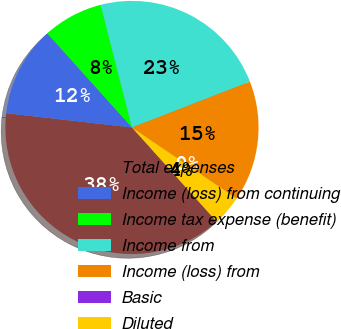<chart> <loc_0><loc_0><loc_500><loc_500><pie_chart><fcel>Total expenses<fcel>Income (loss) from continuing<fcel>Income tax expense (benefit)<fcel>Income from<fcel>Income (loss) from<fcel>Basic<fcel>Diluted<nl><fcel>38.46%<fcel>11.54%<fcel>7.69%<fcel>23.08%<fcel>15.38%<fcel>0.0%<fcel>3.85%<nl></chart> 